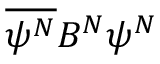Convert formula to latex. <formula><loc_0><loc_0><loc_500><loc_500>\overline { { \psi ^ { N } } } B ^ { N } \psi ^ { N }</formula> 